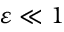<formula> <loc_0><loc_0><loc_500><loc_500>\varepsilon \ll 1</formula> 